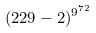<formula> <loc_0><loc_0><loc_500><loc_500>( 2 2 9 - 2 ) ^ { 9 ^ { 7 2 } }</formula> 